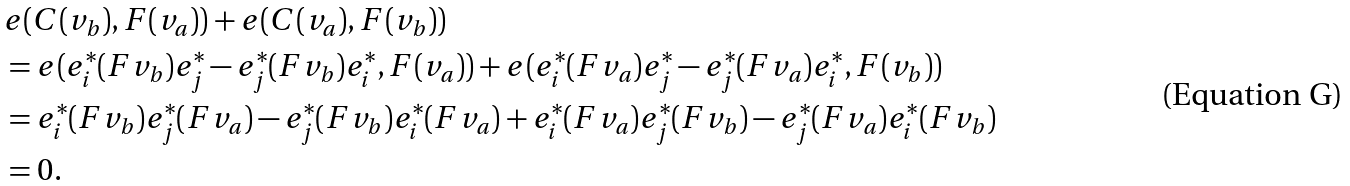Convert formula to latex. <formula><loc_0><loc_0><loc_500><loc_500>& e ( C ( v _ { b } ) , F ( v _ { a } ) ) + e ( C ( v _ { a } ) , F ( v _ { b } ) ) \\ & = e ( e _ { i } ^ { * } ( F v _ { b } ) e _ { j } ^ { * } - e _ { j } ^ { * } ( F v _ { b } ) e _ { i } ^ { * } , F ( v _ { a } ) ) + e ( e _ { i } ^ { * } ( F v _ { a } ) e _ { j } ^ { * } - e _ { j } ^ { * } ( F v _ { a } ) e _ { i } ^ { * } , F ( v _ { b } ) ) \\ & = e _ { i } ^ { * } ( F v _ { b } ) e _ { j } ^ { * } ( F v _ { a } ) - e _ { j } ^ { * } ( F v _ { b } ) e _ { i } ^ { * } ( F v _ { a } ) + e _ { i } ^ { * } ( F v _ { a } ) e _ { j } ^ { * } ( F v _ { b } ) - e _ { j } ^ { * } ( F v _ { a } ) e _ { i } ^ { * } ( F v _ { b } ) \\ & = 0 .</formula> 